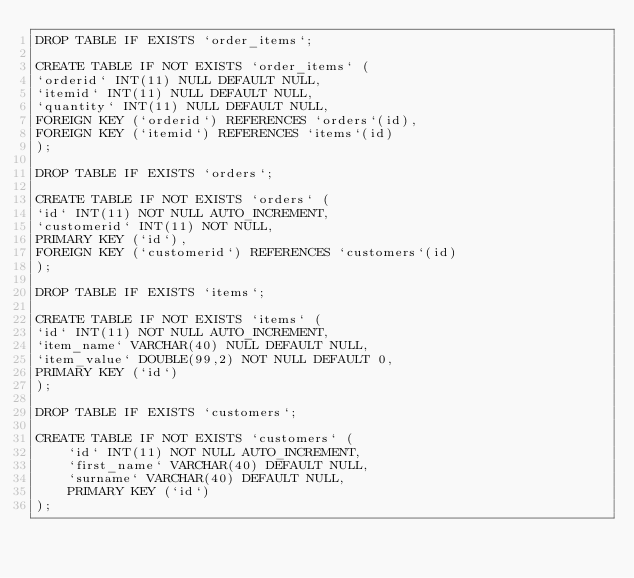Convert code to text. <code><loc_0><loc_0><loc_500><loc_500><_SQL_>DROP TABLE IF EXISTS `order_items`;

CREATE TABLE IF NOT EXISTS `order_items` (
`orderid` INT(11) NULL DEFAULT NULL,
`itemid` INT(11) NULL DEFAULT NULL,
`quantity` INT(11) NULL DEFAULT NULL,
FOREIGN KEY (`orderid`) REFERENCES `orders`(id),
FOREIGN KEY (`itemid`) REFERENCES `items`(id)
);

DROP TABLE IF EXISTS `orders`;

CREATE TABLE IF NOT EXISTS `orders` (
`id` INT(11) NOT NULL AUTO_INCREMENT,
`customerid` INT(11) NOT NULL,
PRIMARY KEY (`id`),
FOREIGN KEY (`customerid`) REFERENCES `customers`(id)
);

DROP TABLE IF EXISTS `items`;

CREATE TABLE IF NOT EXISTS `items` (
`id` INT(11) NOT NULL AUTO_INCREMENT,
`item_name` VARCHAR(40) NULL DEFAULT NULL,
`item_value` DOUBLE(99,2) NOT NULL DEFAULT 0,
PRIMARY KEY (`id`)
);

DROP TABLE IF EXISTS `customers`;

CREATE TABLE IF NOT EXISTS `customers` (
    `id` INT(11) NOT NULL AUTO_INCREMENT,
    `first_name` VARCHAR(40) DEFAULT NULL,
    `surname` VARCHAR(40) DEFAULT NULL,
    PRIMARY KEY (`id`)
);
</code> 